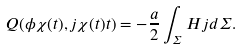<formula> <loc_0><loc_0><loc_500><loc_500>Q ( \phi \chi ( t ) , j \chi ( t ) t ) = - \frac { a } { 2 } \int _ { \Sigma } H j d \Sigma .</formula> 